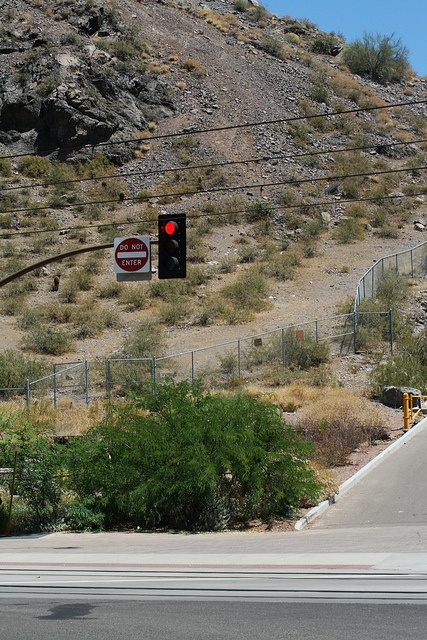Describe the objects in this image and their specific colors. I can see a traffic light in gray, black, red, and maroon tones in this image. 